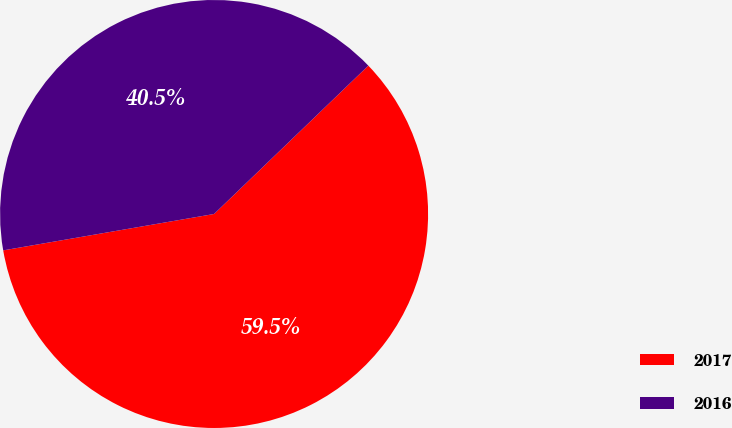Convert chart to OTSL. <chart><loc_0><loc_0><loc_500><loc_500><pie_chart><fcel>2017<fcel>2016<nl><fcel>59.47%<fcel>40.53%<nl></chart> 